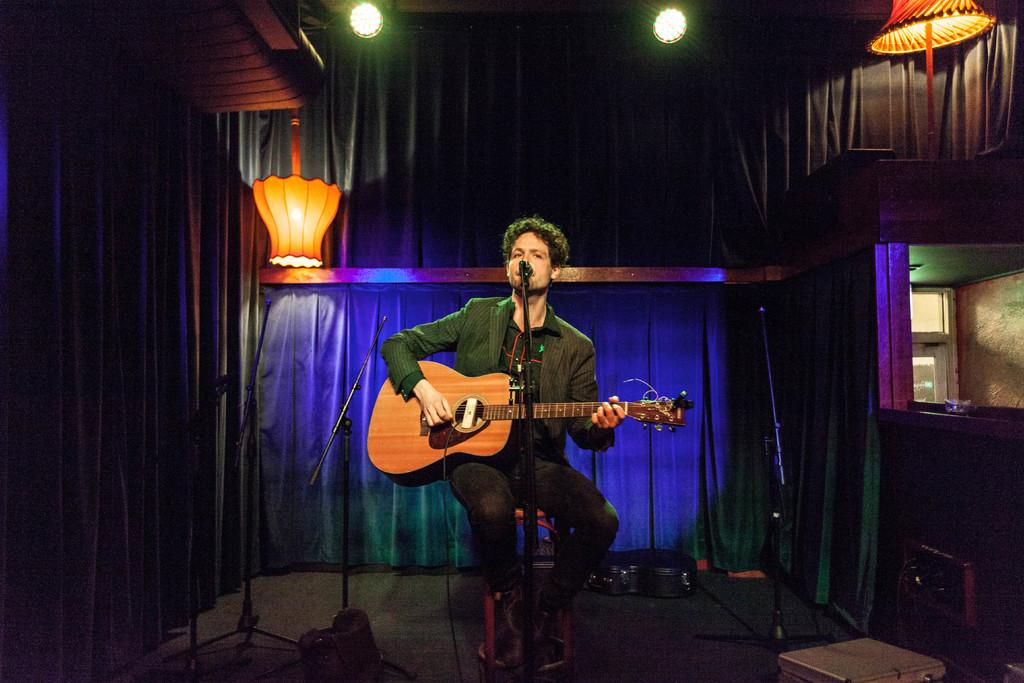Who is the main subject in the image? There is a man in the image. What is the man doing in the image? The man is singing and playing a guitar. What object is the man holding in the image? The man is holding a microphone. Where is the man performing in the image? The man is on a stage. What type of grain is visible on the stage in the image? There is no grain visible on the stage in the image. How many grapes are being used as a prop by the man in the image? There are no grapes present in the image. 